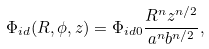Convert formula to latex. <formula><loc_0><loc_0><loc_500><loc_500>\Phi _ { i d } ( R , \phi , z ) = \Phi _ { i d 0 } \frac { R ^ { n } z ^ { n / 2 } } { a ^ { n } b ^ { n / 2 } } ,</formula> 